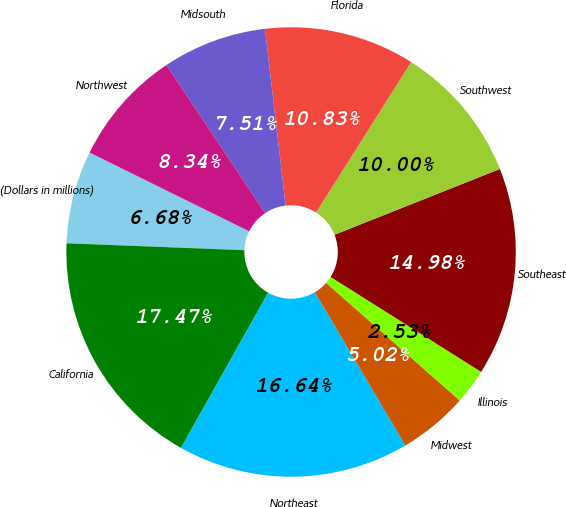Convert chart. <chart><loc_0><loc_0><loc_500><loc_500><pie_chart><fcel>(Dollars in millions)<fcel>California<fcel>Northeast<fcel>Midwest<fcel>Illinois<fcel>Southeast<fcel>Southwest<fcel>Florida<fcel>Midsouth<fcel>Northwest<nl><fcel>6.68%<fcel>17.47%<fcel>16.64%<fcel>5.02%<fcel>2.53%<fcel>14.98%<fcel>10.0%<fcel>10.83%<fcel>7.51%<fcel>8.34%<nl></chart> 